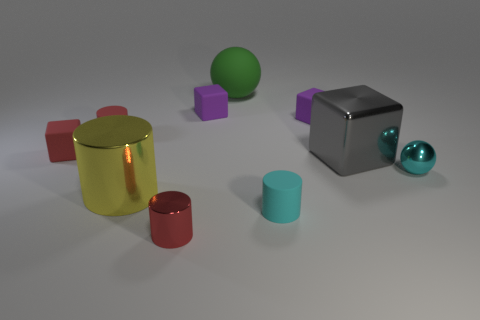Is there a small cyan block made of the same material as the gray thing?
Offer a terse response. No. What number of big green matte spheres are there?
Your response must be concise. 1. Is the big green object made of the same material as the yellow thing to the left of the tiny shiny cylinder?
Provide a short and direct response. No. There is another small cylinder that is the same color as the tiny metallic cylinder; what is it made of?
Your response must be concise. Rubber. What number of things are the same color as the tiny shiny ball?
Offer a terse response. 1. The red block is what size?
Offer a very short reply. Small. Is the shape of the cyan metallic object the same as the small red thing in front of the cyan cylinder?
Your answer should be compact. No. There is a sphere that is made of the same material as the gray thing; what color is it?
Keep it short and to the point. Cyan. There is a yellow cylinder in front of the gray metallic block; how big is it?
Your response must be concise. Large. Is the number of big blocks to the right of the large metal cube less than the number of red matte cylinders?
Offer a terse response. Yes. 